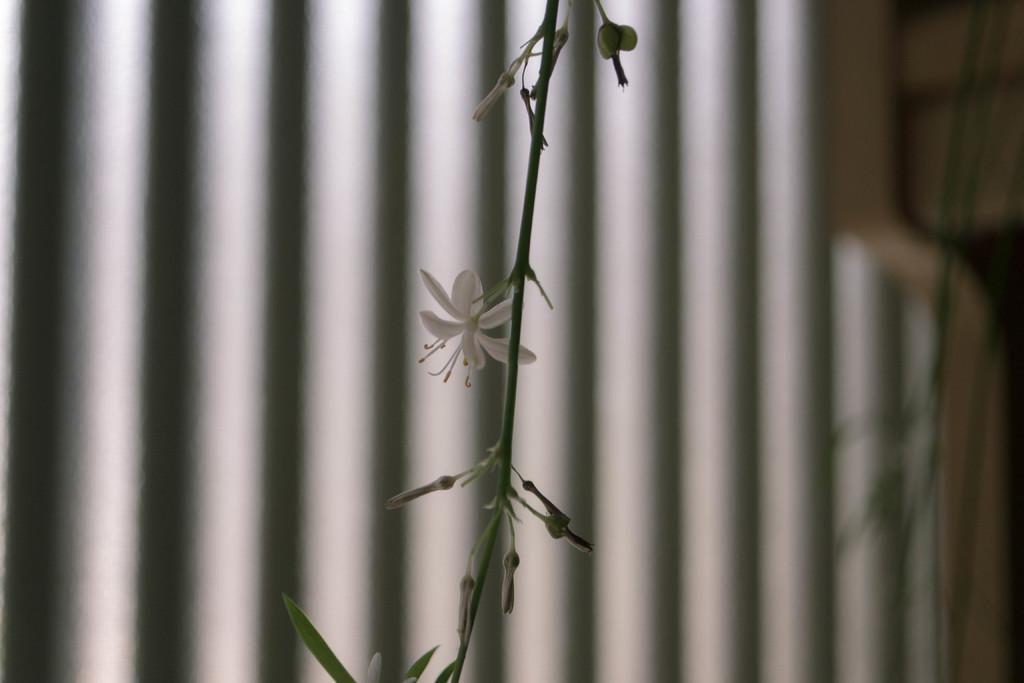In one or two sentences, can you explain what this image depicts? We can see flowers,buds,leaves and stem. In the background it is blurry and we can see rods. 